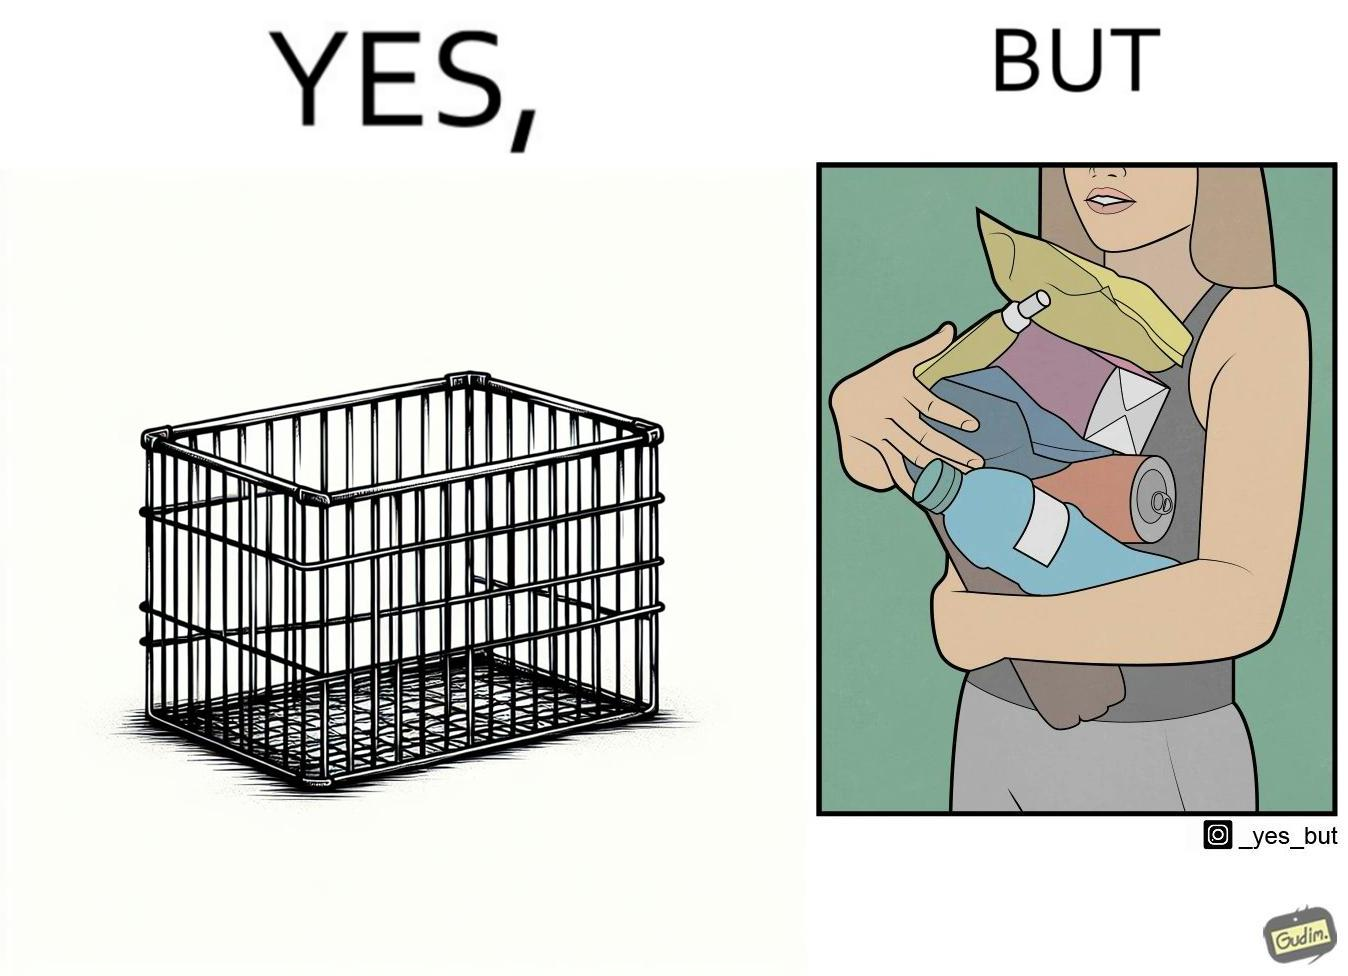Describe what you see in this image. The image is ironic, because even when there are steel frame baskets are available at the supermarkets people prefer carrying the items in hand 